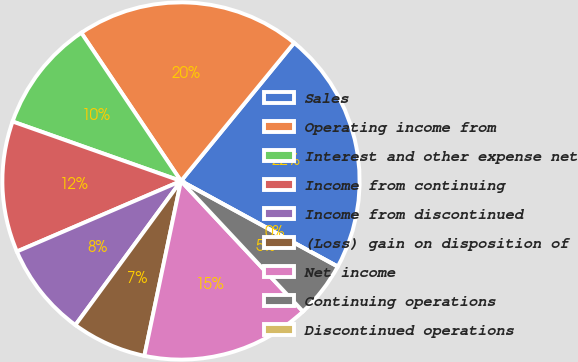<chart> <loc_0><loc_0><loc_500><loc_500><pie_chart><fcel>Sales<fcel>Operating income from<fcel>Interest and other expense net<fcel>Income from continuing<fcel>Income from discontinued<fcel>(Loss) gain on disposition of<fcel>Net income<fcel>Continuing operations<fcel>Discontinued operations<nl><fcel>22.03%<fcel>20.34%<fcel>10.17%<fcel>11.86%<fcel>8.47%<fcel>6.78%<fcel>15.25%<fcel>5.08%<fcel>0.0%<nl></chart> 